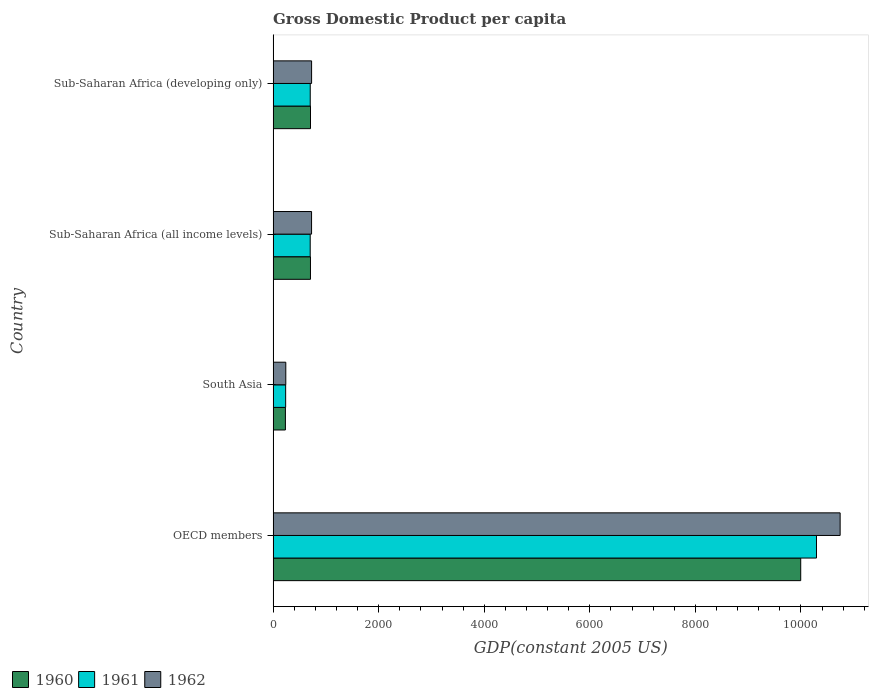How many different coloured bars are there?
Provide a succinct answer. 3. Are the number of bars per tick equal to the number of legend labels?
Keep it short and to the point. Yes. How many bars are there on the 4th tick from the top?
Ensure brevity in your answer.  3. How many bars are there on the 1st tick from the bottom?
Give a very brief answer. 3. What is the GDP per capita in 1960 in South Asia?
Offer a terse response. 232.78. Across all countries, what is the maximum GDP per capita in 1961?
Provide a short and direct response. 1.03e+04. Across all countries, what is the minimum GDP per capita in 1961?
Make the answer very short. 237.38. In which country was the GDP per capita in 1962 maximum?
Provide a succinct answer. OECD members. In which country was the GDP per capita in 1960 minimum?
Ensure brevity in your answer.  South Asia. What is the total GDP per capita in 1961 in the graph?
Provide a succinct answer. 1.19e+04. What is the difference between the GDP per capita in 1962 in Sub-Saharan Africa (all income levels) and that in Sub-Saharan Africa (developing only)?
Your answer should be compact. -0.66. What is the difference between the GDP per capita in 1961 in Sub-Saharan Africa (developing only) and the GDP per capita in 1960 in South Asia?
Your answer should be very brief. 470.36. What is the average GDP per capita in 1962 per country?
Offer a terse response. 3109.8. What is the difference between the GDP per capita in 1960 and GDP per capita in 1961 in South Asia?
Your answer should be very brief. -4.6. What is the ratio of the GDP per capita in 1961 in OECD members to that in Sub-Saharan Africa (developing only)?
Ensure brevity in your answer.  14.64. What is the difference between the highest and the second highest GDP per capita in 1961?
Provide a succinct answer. 9590.8. What is the difference between the highest and the lowest GDP per capita in 1960?
Ensure brevity in your answer.  9762.55. In how many countries, is the GDP per capita in 1960 greater than the average GDP per capita in 1960 taken over all countries?
Keep it short and to the point. 1. What is the difference between two consecutive major ticks on the X-axis?
Give a very brief answer. 2000. Does the graph contain any zero values?
Your response must be concise. No. Where does the legend appear in the graph?
Your response must be concise. Bottom left. How are the legend labels stacked?
Your answer should be very brief. Horizontal. What is the title of the graph?
Ensure brevity in your answer.  Gross Domestic Product per capita. What is the label or title of the X-axis?
Your answer should be very brief. GDP(constant 2005 US). What is the GDP(constant 2005 US) of 1960 in OECD members?
Provide a short and direct response. 9995.33. What is the GDP(constant 2005 US) of 1961 in OECD members?
Provide a succinct answer. 1.03e+04. What is the GDP(constant 2005 US) of 1962 in OECD members?
Your response must be concise. 1.07e+04. What is the GDP(constant 2005 US) in 1960 in South Asia?
Keep it short and to the point. 232.78. What is the GDP(constant 2005 US) of 1961 in South Asia?
Offer a very short reply. 237.38. What is the GDP(constant 2005 US) of 1962 in South Asia?
Your answer should be compact. 240.15. What is the GDP(constant 2005 US) of 1960 in Sub-Saharan Africa (all income levels)?
Make the answer very short. 707.4. What is the GDP(constant 2005 US) of 1961 in Sub-Saharan Africa (all income levels)?
Your answer should be very brief. 702.48. What is the GDP(constant 2005 US) of 1962 in Sub-Saharan Africa (all income levels)?
Keep it short and to the point. 728.15. What is the GDP(constant 2005 US) of 1960 in Sub-Saharan Africa (developing only)?
Offer a terse response. 708.03. What is the GDP(constant 2005 US) of 1961 in Sub-Saharan Africa (developing only)?
Give a very brief answer. 703.14. What is the GDP(constant 2005 US) in 1962 in Sub-Saharan Africa (developing only)?
Your answer should be very brief. 728.81. Across all countries, what is the maximum GDP(constant 2005 US) of 1960?
Your answer should be very brief. 9995.33. Across all countries, what is the maximum GDP(constant 2005 US) in 1961?
Ensure brevity in your answer.  1.03e+04. Across all countries, what is the maximum GDP(constant 2005 US) of 1962?
Your answer should be compact. 1.07e+04. Across all countries, what is the minimum GDP(constant 2005 US) of 1960?
Ensure brevity in your answer.  232.78. Across all countries, what is the minimum GDP(constant 2005 US) in 1961?
Your answer should be very brief. 237.38. Across all countries, what is the minimum GDP(constant 2005 US) in 1962?
Make the answer very short. 240.15. What is the total GDP(constant 2005 US) in 1960 in the graph?
Ensure brevity in your answer.  1.16e+04. What is the total GDP(constant 2005 US) of 1961 in the graph?
Give a very brief answer. 1.19e+04. What is the total GDP(constant 2005 US) in 1962 in the graph?
Offer a terse response. 1.24e+04. What is the difference between the GDP(constant 2005 US) of 1960 in OECD members and that in South Asia?
Provide a short and direct response. 9762.55. What is the difference between the GDP(constant 2005 US) of 1961 in OECD members and that in South Asia?
Make the answer very short. 1.01e+04. What is the difference between the GDP(constant 2005 US) of 1962 in OECD members and that in South Asia?
Your response must be concise. 1.05e+04. What is the difference between the GDP(constant 2005 US) in 1960 in OECD members and that in Sub-Saharan Africa (all income levels)?
Offer a very short reply. 9287.92. What is the difference between the GDP(constant 2005 US) of 1961 in OECD members and that in Sub-Saharan Africa (all income levels)?
Your answer should be compact. 9591.46. What is the difference between the GDP(constant 2005 US) of 1962 in OECD members and that in Sub-Saharan Africa (all income levels)?
Provide a succinct answer. 1.00e+04. What is the difference between the GDP(constant 2005 US) in 1960 in OECD members and that in Sub-Saharan Africa (developing only)?
Your answer should be compact. 9287.29. What is the difference between the GDP(constant 2005 US) in 1961 in OECD members and that in Sub-Saharan Africa (developing only)?
Your answer should be compact. 9590.8. What is the difference between the GDP(constant 2005 US) in 1962 in OECD members and that in Sub-Saharan Africa (developing only)?
Provide a succinct answer. 1.00e+04. What is the difference between the GDP(constant 2005 US) in 1960 in South Asia and that in Sub-Saharan Africa (all income levels)?
Provide a succinct answer. -474.62. What is the difference between the GDP(constant 2005 US) of 1961 in South Asia and that in Sub-Saharan Africa (all income levels)?
Your answer should be compact. -465.1. What is the difference between the GDP(constant 2005 US) in 1962 in South Asia and that in Sub-Saharan Africa (all income levels)?
Your answer should be very brief. -488. What is the difference between the GDP(constant 2005 US) of 1960 in South Asia and that in Sub-Saharan Africa (developing only)?
Your response must be concise. -475.26. What is the difference between the GDP(constant 2005 US) of 1961 in South Asia and that in Sub-Saharan Africa (developing only)?
Provide a succinct answer. -465.76. What is the difference between the GDP(constant 2005 US) in 1962 in South Asia and that in Sub-Saharan Africa (developing only)?
Your answer should be very brief. -488.66. What is the difference between the GDP(constant 2005 US) in 1960 in Sub-Saharan Africa (all income levels) and that in Sub-Saharan Africa (developing only)?
Your answer should be very brief. -0.63. What is the difference between the GDP(constant 2005 US) in 1961 in Sub-Saharan Africa (all income levels) and that in Sub-Saharan Africa (developing only)?
Provide a short and direct response. -0.66. What is the difference between the GDP(constant 2005 US) of 1962 in Sub-Saharan Africa (all income levels) and that in Sub-Saharan Africa (developing only)?
Ensure brevity in your answer.  -0.66. What is the difference between the GDP(constant 2005 US) in 1960 in OECD members and the GDP(constant 2005 US) in 1961 in South Asia?
Ensure brevity in your answer.  9757.94. What is the difference between the GDP(constant 2005 US) in 1960 in OECD members and the GDP(constant 2005 US) in 1962 in South Asia?
Your response must be concise. 9755.17. What is the difference between the GDP(constant 2005 US) in 1961 in OECD members and the GDP(constant 2005 US) in 1962 in South Asia?
Provide a succinct answer. 1.01e+04. What is the difference between the GDP(constant 2005 US) of 1960 in OECD members and the GDP(constant 2005 US) of 1961 in Sub-Saharan Africa (all income levels)?
Your response must be concise. 9292.85. What is the difference between the GDP(constant 2005 US) of 1960 in OECD members and the GDP(constant 2005 US) of 1962 in Sub-Saharan Africa (all income levels)?
Offer a terse response. 9267.18. What is the difference between the GDP(constant 2005 US) in 1961 in OECD members and the GDP(constant 2005 US) in 1962 in Sub-Saharan Africa (all income levels)?
Ensure brevity in your answer.  9565.79. What is the difference between the GDP(constant 2005 US) in 1960 in OECD members and the GDP(constant 2005 US) in 1961 in Sub-Saharan Africa (developing only)?
Your response must be concise. 9292.18. What is the difference between the GDP(constant 2005 US) in 1960 in OECD members and the GDP(constant 2005 US) in 1962 in Sub-Saharan Africa (developing only)?
Offer a very short reply. 9266.51. What is the difference between the GDP(constant 2005 US) of 1961 in OECD members and the GDP(constant 2005 US) of 1962 in Sub-Saharan Africa (developing only)?
Give a very brief answer. 9565.13. What is the difference between the GDP(constant 2005 US) in 1960 in South Asia and the GDP(constant 2005 US) in 1961 in Sub-Saharan Africa (all income levels)?
Your response must be concise. -469.7. What is the difference between the GDP(constant 2005 US) of 1960 in South Asia and the GDP(constant 2005 US) of 1962 in Sub-Saharan Africa (all income levels)?
Keep it short and to the point. -495.37. What is the difference between the GDP(constant 2005 US) of 1961 in South Asia and the GDP(constant 2005 US) of 1962 in Sub-Saharan Africa (all income levels)?
Provide a short and direct response. -490.77. What is the difference between the GDP(constant 2005 US) of 1960 in South Asia and the GDP(constant 2005 US) of 1961 in Sub-Saharan Africa (developing only)?
Offer a very short reply. -470.36. What is the difference between the GDP(constant 2005 US) of 1960 in South Asia and the GDP(constant 2005 US) of 1962 in Sub-Saharan Africa (developing only)?
Your answer should be very brief. -496.04. What is the difference between the GDP(constant 2005 US) in 1961 in South Asia and the GDP(constant 2005 US) in 1962 in Sub-Saharan Africa (developing only)?
Your answer should be compact. -491.43. What is the difference between the GDP(constant 2005 US) of 1960 in Sub-Saharan Africa (all income levels) and the GDP(constant 2005 US) of 1961 in Sub-Saharan Africa (developing only)?
Give a very brief answer. 4.26. What is the difference between the GDP(constant 2005 US) in 1960 in Sub-Saharan Africa (all income levels) and the GDP(constant 2005 US) in 1962 in Sub-Saharan Africa (developing only)?
Ensure brevity in your answer.  -21.41. What is the difference between the GDP(constant 2005 US) of 1961 in Sub-Saharan Africa (all income levels) and the GDP(constant 2005 US) of 1962 in Sub-Saharan Africa (developing only)?
Your response must be concise. -26.33. What is the average GDP(constant 2005 US) of 1960 per country?
Ensure brevity in your answer.  2910.89. What is the average GDP(constant 2005 US) in 1961 per country?
Give a very brief answer. 2984.24. What is the average GDP(constant 2005 US) in 1962 per country?
Offer a terse response. 3109.8. What is the difference between the GDP(constant 2005 US) in 1960 and GDP(constant 2005 US) in 1961 in OECD members?
Keep it short and to the point. -298.62. What is the difference between the GDP(constant 2005 US) of 1960 and GDP(constant 2005 US) of 1962 in OECD members?
Give a very brief answer. -746.74. What is the difference between the GDP(constant 2005 US) of 1961 and GDP(constant 2005 US) of 1962 in OECD members?
Make the answer very short. -448.13. What is the difference between the GDP(constant 2005 US) of 1960 and GDP(constant 2005 US) of 1961 in South Asia?
Your response must be concise. -4.6. What is the difference between the GDP(constant 2005 US) of 1960 and GDP(constant 2005 US) of 1962 in South Asia?
Offer a terse response. -7.37. What is the difference between the GDP(constant 2005 US) in 1961 and GDP(constant 2005 US) in 1962 in South Asia?
Your answer should be compact. -2.77. What is the difference between the GDP(constant 2005 US) in 1960 and GDP(constant 2005 US) in 1961 in Sub-Saharan Africa (all income levels)?
Provide a succinct answer. 4.92. What is the difference between the GDP(constant 2005 US) in 1960 and GDP(constant 2005 US) in 1962 in Sub-Saharan Africa (all income levels)?
Ensure brevity in your answer.  -20.75. What is the difference between the GDP(constant 2005 US) of 1961 and GDP(constant 2005 US) of 1962 in Sub-Saharan Africa (all income levels)?
Give a very brief answer. -25.67. What is the difference between the GDP(constant 2005 US) of 1960 and GDP(constant 2005 US) of 1961 in Sub-Saharan Africa (developing only)?
Keep it short and to the point. 4.89. What is the difference between the GDP(constant 2005 US) of 1960 and GDP(constant 2005 US) of 1962 in Sub-Saharan Africa (developing only)?
Offer a terse response. -20.78. What is the difference between the GDP(constant 2005 US) of 1961 and GDP(constant 2005 US) of 1962 in Sub-Saharan Africa (developing only)?
Offer a very short reply. -25.67. What is the ratio of the GDP(constant 2005 US) in 1960 in OECD members to that in South Asia?
Provide a succinct answer. 42.94. What is the ratio of the GDP(constant 2005 US) of 1961 in OECD members to that in South Asia?
Offer a terse response. 43.36. What is the ratio of the GDP(constant 2005 US) of 1962 in OECD members to that in South Asia?
Offer a terse response. 44.73. What is the ratio of the GDP(constant 2005 US) of 1960 in OECD members to that in Sub-Saharan Africa (all income levels)?
Offer a terse response. 14.13. What is the ratio of the GDP(constant 2005 US) of 1961 in OECD members to that in Sub-Saharan Africa (all income levels)?
Offer a very short reply. 14.65. What is the ratio of the GDP(constant 2005 US) of 1962 in OECD members to that in Sub-Saharan Africa (all income levels)?
Your response must be concise. 14.75. What is the ratio of the GDP(constant 2005 US) of 1960 in OECD members to that in Sub-Saharan Africa (developing only)?
Your response must be concise. 14.12. What is the ratio of the GDP(constant 2005 US) of 1961 in OECD members to that in Sub-Saharan Africa (developing only)?
Ensure brevity in your answer.  14.64. What is the ratio of the GDP(constant 2005 US) of 1962 in OECD members to that in Sub-Saharan Africa (developing only)?
Offer a terse response. 14.74. What is the ratio of the GDP(constant 2005 US) of 1960 in South Asia to that in Sub-Saharan Africa (all income levels)?
Your answer should be very brief. 0.33. What is the ratio of the GDP(constant 2005 US) in 1961 in South Asia to that in Sub-Saharan Africa (all income levels)?
Your response must be concise. 0.34. What is the ratio of the GDP(constant 2005 US) in 1962 in South Asia to that in Sub-Saharan Africa (all income levels)?
Your answer should be compact. 0.33. What is the ratio of the GDP(constant 2005 US) in 1960 in South Asia to that in Sub-Saharan Africa (developing only)?
Provide a short and direct response. 0.33. What is the ratio of the GDP(constant 2005 US) in 1961 in South Asia to that in Sub-Saharan Africa (developing only)?
Provide a short and direct response. 0.34. What is the ratio of the GDP(constant 2005 US) of 1962 in South Asia to that in Sub-Saharan Africa (developing only)?
Keep it short and to the point. 0.33. What is the ratio of the GDP(constant 2005 US) of 1960 in Sub-Saharan Africa (all income levels) to that in Sub-Saharan Africa (developing only)?
Ensure brevity in your answer.  1. What is the ratio of the GDP(constant 2005 US) in 1961 in Sub-Saharan Africa (all income levels) to that in Sub-Saharan Africa (developing only)?
Keep it short and to the point. 1. What is the ratio of the GDP(constant 2005 US) in 1962 in Sub-Saharan Africa (all income levels) to that in Sub-Saharan Africa (developing only)?
Your answer should be compact. 1. What is the difference between the highest and the second highest GDP(constant 2005 US) of 1960?
Your answer should be compact. 9287.29. What is the difference between the highest and the second highest GDP(constant 2005 US) in 1961?
Keep it short and to the point. 9590.8. What is the difference between the highest and the second highest GDP(constant 2005 US) in 1962?
Provide a short and direct response. 1.00e+04. What is the difference between the highest and the lowest GDP(constant 2005 US) of 1960?
Provide a short and direct response. 9762.55. What is the difference between the highest and the lowest GDP(constant 2005 US) of 1961?
Provide a short and direct response. 1.01e+04. What is the difference between the highest and the lowest GDP(constant 2005 US) of 1962?
Give a very brief answer. 1.05e+04. 